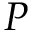Convert formula to latex. <formula><loc_0><loc_0><loc_500><loc_500>P</formula> 